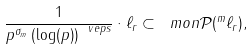<formula> <loc_0><loc_0><loc_500><loc_500>\frac { 1 } { p ^ { \sigma _ { m } } \left ( \log ( p ) \right ) ^ { \ v e p s } } \cdot \ell _ { r } \subset \ m o n \mathcal { P } ( ^ { m } \ell _ { r } ) ,</formula> 